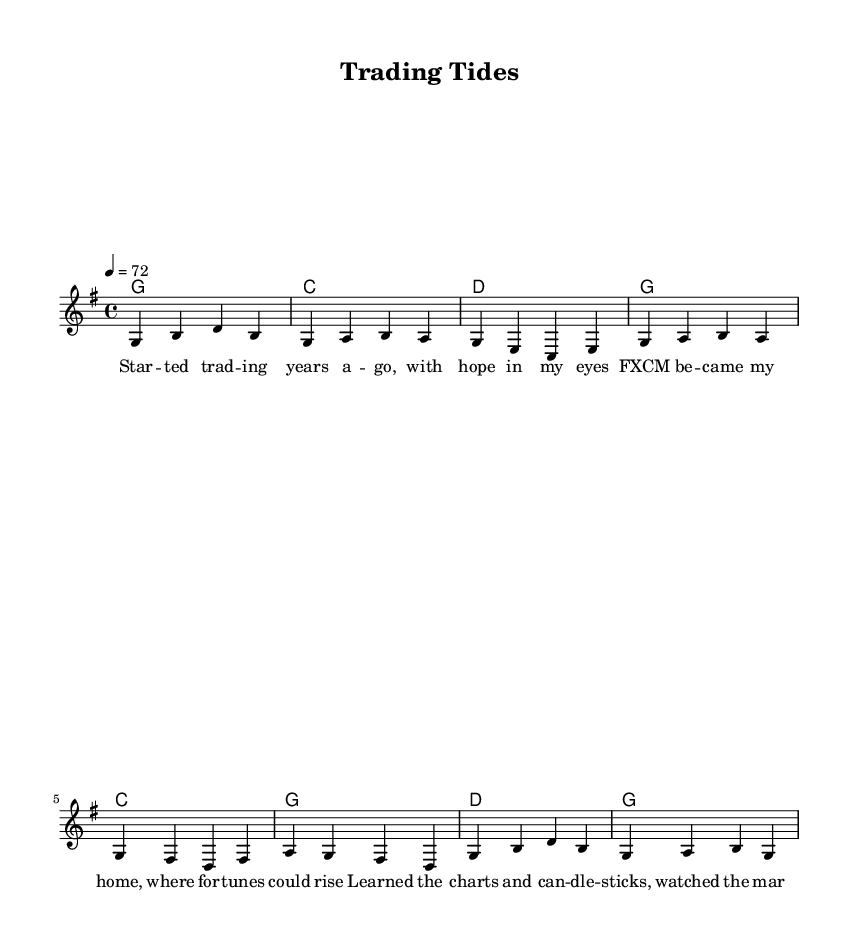What is the key signature of this music? The key signature is G major, which has one sharp (F#). You can identify the key signature by looking at the symbols at the beginning of the staff.
Answer: G major What is the time signature of this music? The time signature is 4/4, which is indicated at the beginning of the sheet music. This means there are four beats in each measure and the quarter note gets one beat.
Answer: 4/4 What is the tempo marking of this music? The tempo marking is 72 beats per minute, indicated in the section marked with \tempo. This determines the speed of the piece.
Answer: 72 How many verses are there in the song? There is one verse section as indicated by the lyrics under the melody. The structure appears to be a verse followed by a chorus, so it repeats this form.
Answer: One What chord is played during the chorus? The chords during the chorus include C, G, and D, as specified in the chord mode section under chorusChords. These provide harmonic support for the melody.
Answer: C, G, D What lyrical theme is reflected in the verse? The theme reflects the experiences and challenges of forex trading, as it mentions starting trading with hope, learning about the markets, and the ups and downs of trading. This aligns with the struggles faced over a long career.
Answer: Trading experiences and challenges 